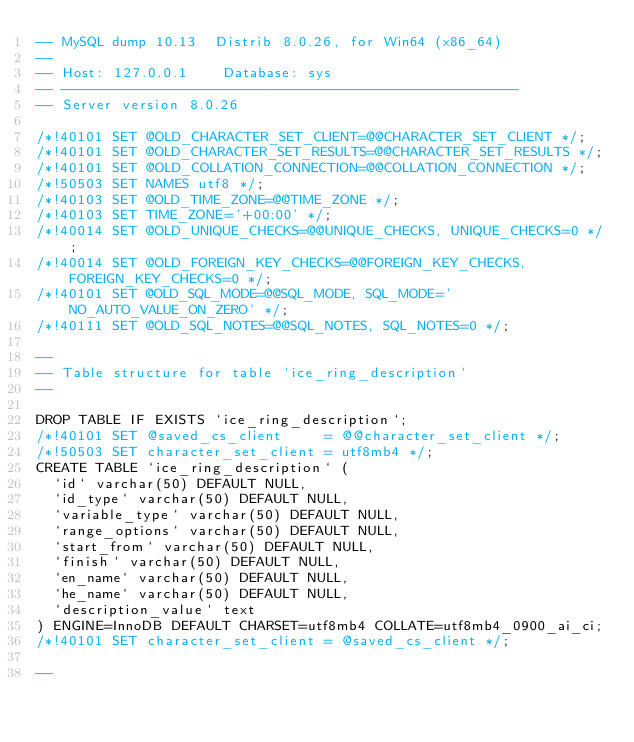<code> <loc_0><loc_0><loc_500><loc_500><_SQL_>-- MySQL dump 10.13  Distrib 8.0.26, for Win64 (x86_64)
--
-- Host: 127.0.0.1    Database: sys
-- ------------------------------------------------------
-- Server version	8.0.26

/*!40101 SET @OLD_CHARACTER_SET_CLIENT=@@CHARACTER_SET_CLIENT */;
/*!40101 SET @OLD_CHARACTER_SET_RESULTS=@@CHARACTER_SET_RESULTS */;
/*!40101 SET @OLD_COLLATION_CONNECTION=@@COLLATION_CONNECTION */;
/*!50503 SET NAMES utf8 */;
/*!40103 SET @OLD_TIME_ZONE=@@TIME_ZONE */;
/*!40103 SET TIME_ZONE='+00:00' */;
/*!40014 SET @OLD_UNIQUE_CHECKS=@@UNIQUE_CHECKS, UNIQUE_CHECKS=0 */;
/*!40014 SET @OLD_FOREIGN_KEY_CHECKS=@@FOREIGN_KEY_CHECKS, FOREIGN_KEY_CHECKS=0 */;
/*!40101 SET @OLD_SQL_MODE=@@SQL_MODE, SQL_MODE='NO_AUTO_VALUE_ON_ZERO' */;
/*!40111 SET @OLD_SQL_NOTES=@@SQL_NOTES, SQL_NOTES=0 */;

--
-- Table structure for table `ice_ring_description`
--

DROP TABLE IF EXISTS `ice_ring_description`;
/*!40101 SET @saved_cs_client     = @@character_set_client */;
/*!50503 SET character_set_client = utf8mb4 */;
CREATE TABLE `ice_ring_description` (
  `id` varchar(50) DEFAULT NULL,
  `id_type` varchar(50) DEFAULT NULL,
  `variable_type` varchar(50) DEFAULT NULL,
  `range_options` varchar(50) DEFAULT NULL,
  `start_from` varchar(50) DEFAULT NULL,
  `finish` varchar(50) DEFAULT NULL,
  `en_name` varchar(50) DEFAULT NULL,
  `he_name` varchar(50) DEFAULT NULL,
  `description_value` text
) ENGINE=InnoDB DEFAULT CHARSET=utf8mb4 COLLATE=utf8mb4_0900_ai_ci;
/*!40101 SET character_set_client = @saved_cs_client */;

--</code> 